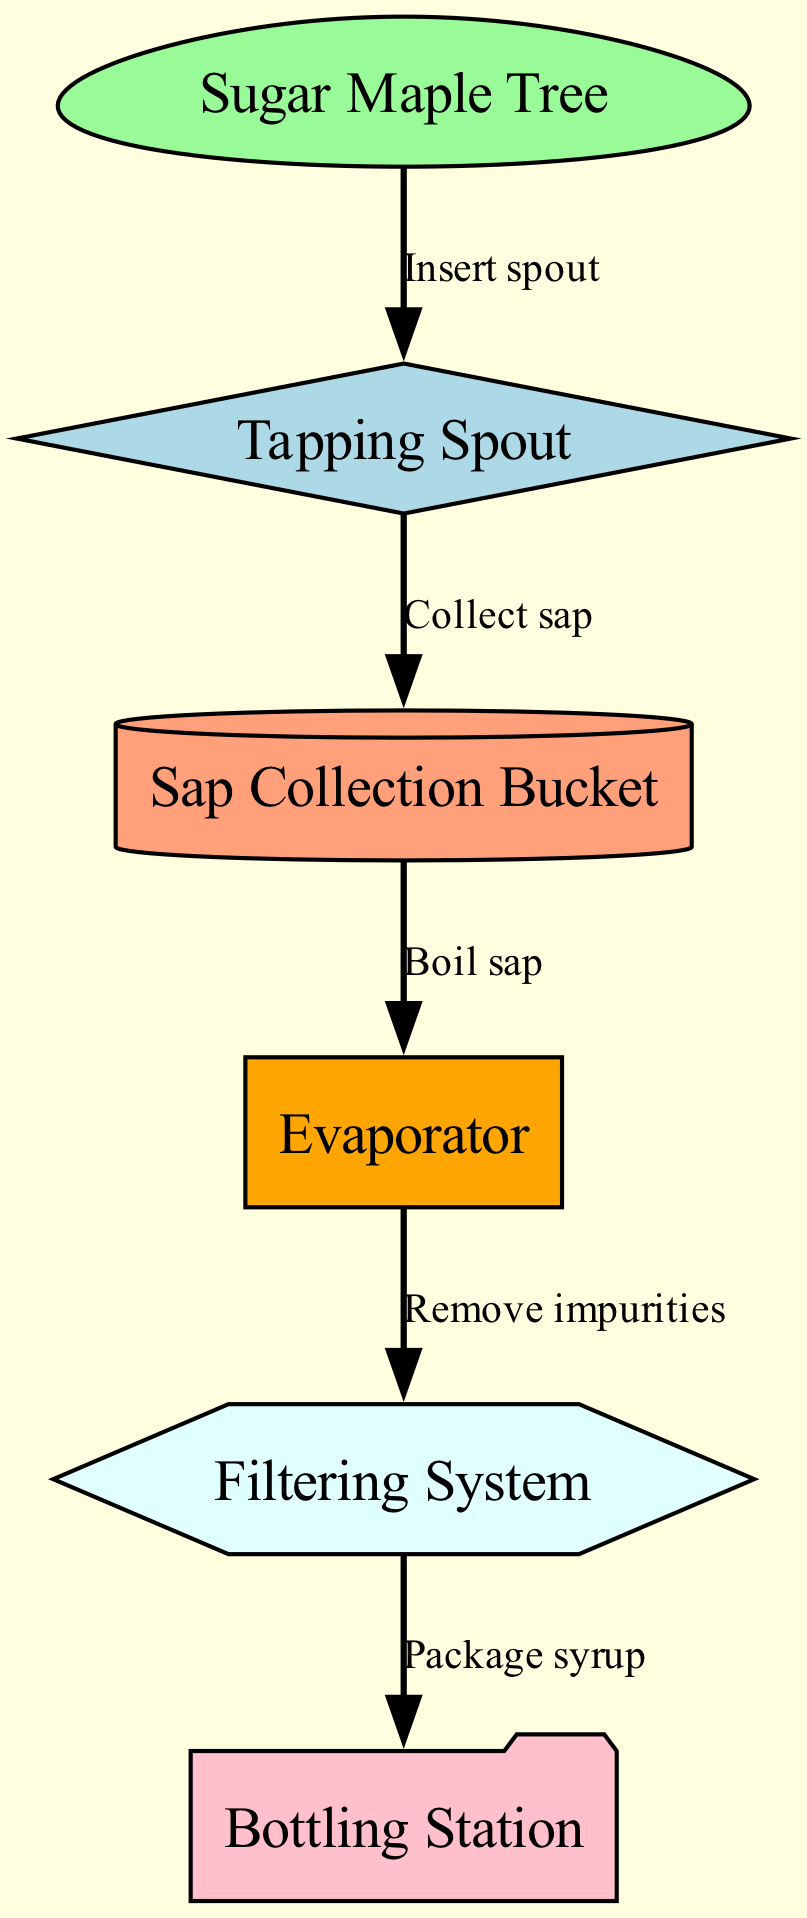What is the first step in the maple syrup production process? The first step is indicated by the starting point at "Sugar Maple Tree," where the tapping process begins.
Answer: Sugar Maple Tree What is used to collect the sap after tapping? The diagram shows that after inserting the spout, sap is collected in a "Sap Collection Bucket."
Answer: Sap Collection Bucket How many nodes are there in the diagram? By counting each unique representing element in the diagram, we find a total of 6 nodes listed.
Answer: 6 What is the function of the "Evaporator"? The "Evaporator" is illustrated as the step where the sap is boiled, indicating its key role in the concentration of the syrup.
Answer: Boil sap What type of system is used to remove impurities from the sap? The system used for purification is referred to as a "Filtering System," which is specifically mentioned in the diagram sequence.
Answer: Filtering System After boiling, what is the next step before bottling? The process flow shows that after boiling sap, the next step is to remove impurities through the "Filtering System" before bottling.
Answer: Remove impurities Which node is labeled as the final step in the process? The final step is depicted as the "Bottling Station," indicating where the syrup is packaged for sale or distribution.
Answer: Bottling Station What relationship exists between the "Tapping Spout" and the "Sap Collection Bucket"? The diagram indicates a direct relationship, where the tapping spout is used to collect the sap in the designated collection bucket.
Answer: Collect sap What shape is used to represent the "Filtering System"? According to the diagram's node styles, the "Filtering System" is represented using a hexagonal shape.
Answer: Hexagon Which step involves boiling the sap? The "Evaporator" node is specifically connected to boiling the sap as part of the syrup production process.
Answer: Evaporator 